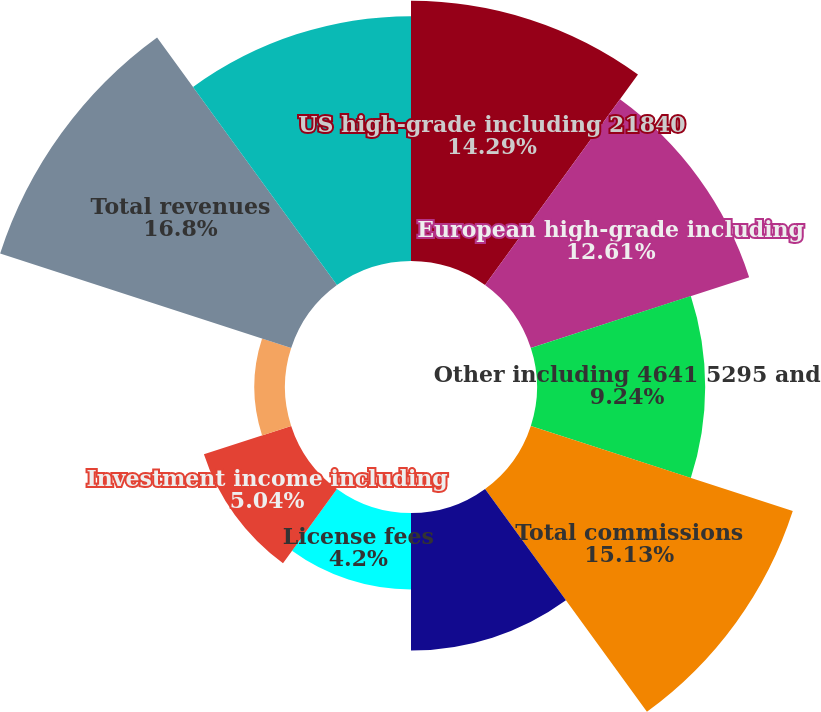<chart> <loc_0><loc_0><loc_500><loc_500><pie_chart><fcel>US high-grade including 21840<fcel>European high-grade including<fcel>Other including 4641 5295 and<fcel>Total commissions<fcel>Information and user access<fcel>License fees<fcel>Investment income including<fcel>the years ended December 31<fcel>Total revenues<fcel>Employee compensation and<nl><fcel>14.29%<fcel>12.61%<fcel>9.24%<fcel>15.13%<fcel>7.56%<fcel>4.2%<fcel>5.04%<fcel>1.68%<fcel>16.81%<fcel>13.45%<nl></chart> 